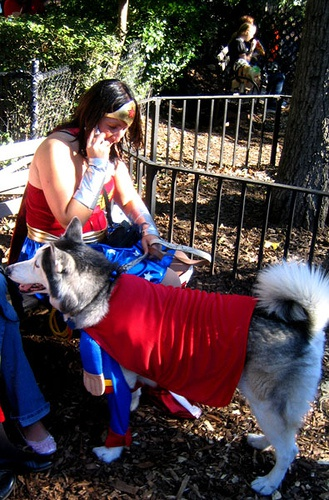Describe the objects in this image and their specific colors. I can see dog in black, maroon, brown, and gray tones, people in black, white, brown, and gray tones, people in black, navy, blue, and darkblue tones, bench in black, white, darkgray, tan, and gray tones, and handbag in black, navy, gray, and maroon tones in this image. 